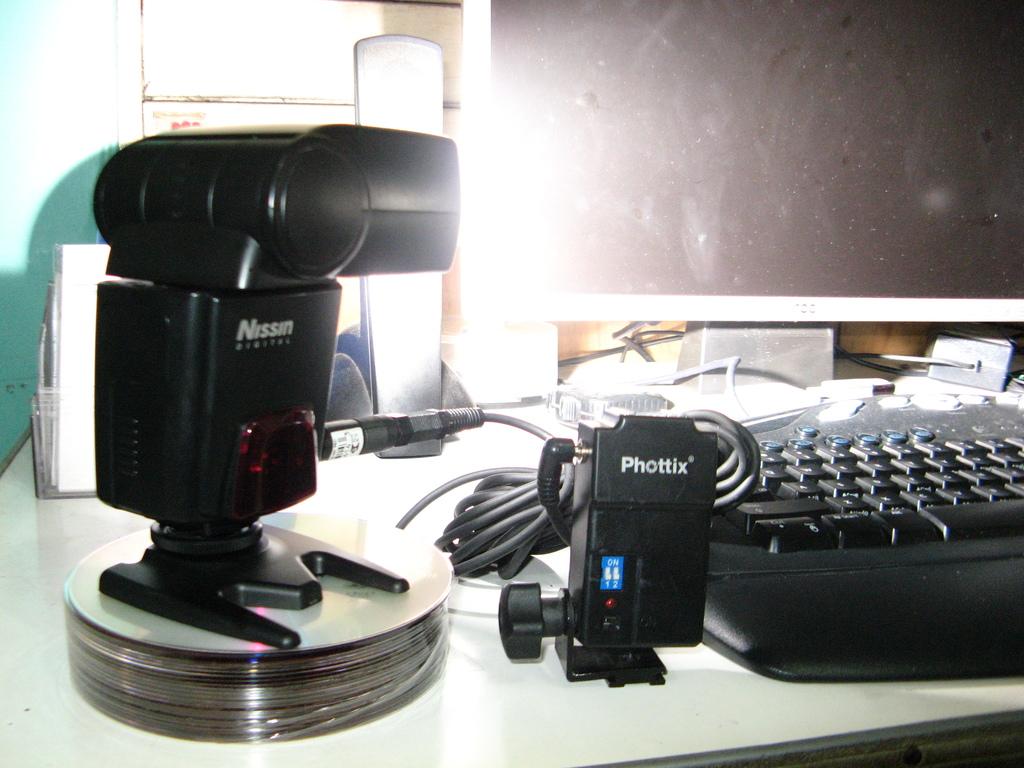What is the brand of the device in the middle?
Your response must be concise. Phottix. What is the brand of the device on top of the cd stack?
Offer a very short reply. Nissin. 